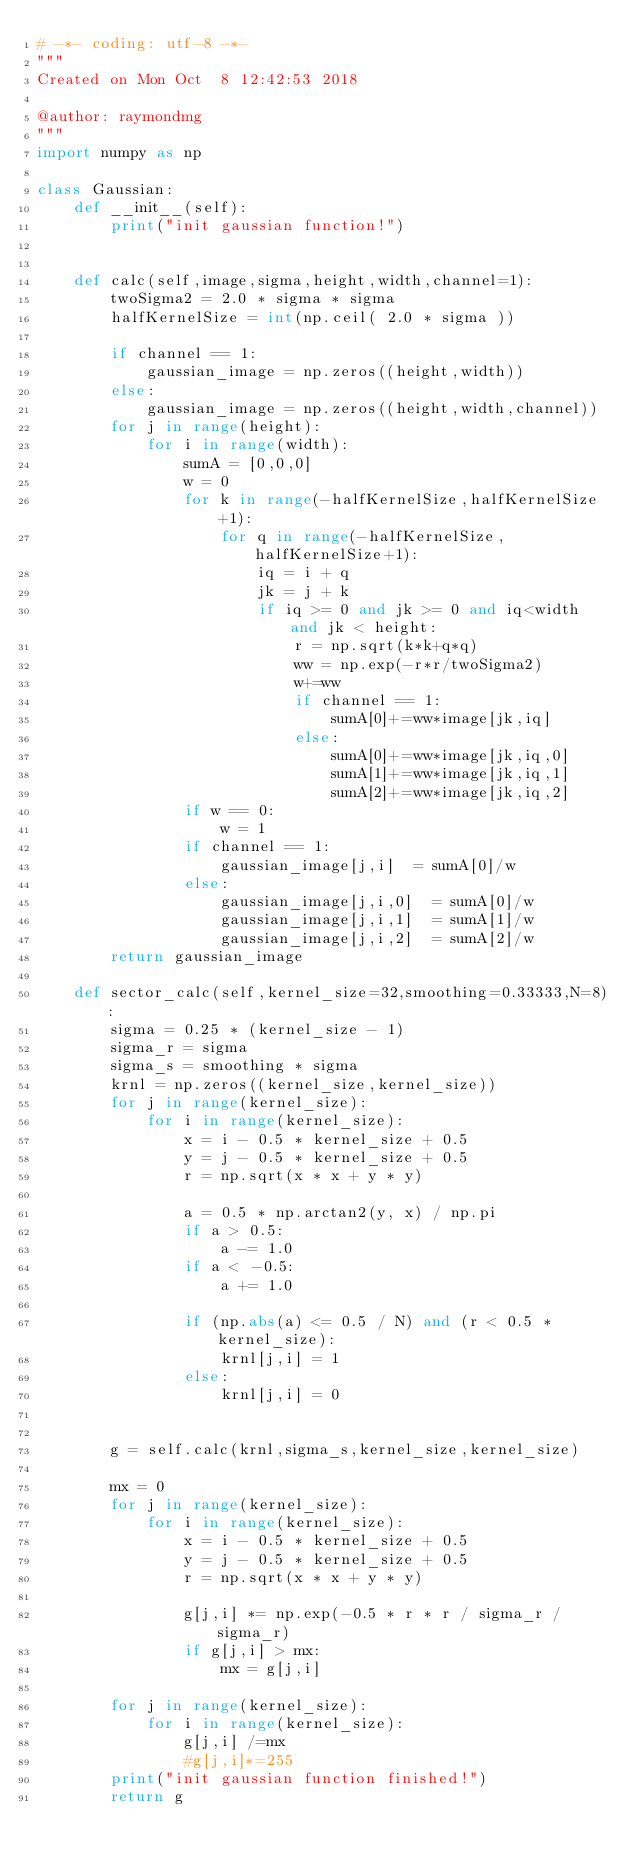<code> <loc_0><loc_0><loc_500><loc_500><_Python_># -*- coding: utf-8 -*-
"""
Created on Mon Oct  8 12:42:53 2018

@author: raymondmg
"""
import numpy as np

class Gaussian:
    def __init__(self):
        print("init gaussian function!")

    
    def calc(self,image,sigma,height,width,channel=1):
        twoSigma2 = 2.0 * sigma * sigma
        halfKernelSize = int(np.ceil( 2.0 * sigma ))
        
        if channel == 1:
            gaussian_image = np.zeros((height,width))
        else:
            gaussian_image = np.zeros((height,width,channel))
        for j in range(height):
            for i in range(width):
                sumA = [0,0,0]
                w = 0
                for k in range(-halfKernelSize,halfKernelSize+1):
                    for q in range(-halfKernelSize,halfKernelSize+1):
                        iq = i + q
                        jk = j + k
                        if iq >= 0 and jk >= 0 and iq<width and jk < height:
                            r = np.sqrt(k*k+q*q)
                            ww = np.exp(-r*r/twoSigma2)
                            w+=ww
                            if channel == 1:
                                sumA[0]+=ww*image[jk,iq]
                            else:
                                sumA[0]+=ww*image[jk,iq,0]
                                sumA[1]+=ww*image[jk,iq,1]
                                sumA[2]+=ww*image[jk,iq,2]
                if w == 0:
                    w = 1
                if channel == 1:
                    gaussian_image[j,i]  = sumA[0]/w
                else:
                    gaussian_image[j,i,0]  = sumA[0]/w
                    gaussian_image[j,i,1]  = sumA[1]/w
                    gaussian_image[j,i,2]  = sumA[2]/w
        return gaussian_image
    
    def sector_calc(self,kernel_size=32,smoothing=0.33333,N=8):
        sigma = 0.25 * (kernel_size - 1)
        sigma_r = sigma
        sigma_s = smoothing * sigma
        krnl = np.zeros((kernel_size,kernel_size))
        for j in range(kernel_size):
            for i in range(kernel_size):
                x = i - 0.5 * kernel_size + 0.5
                y = j - 0.5 * kernel_size + 0.5
                r = np.sqrt(x * x + y * y)
                
                a = 0.5 * np.arctan2(y, x) / np.pi
                if a > 0.5:
                    a -= 1.0
                if a < -0.5:
                    a += 1.0

                if (np.abs(a) <= 0.5 / N) and (r < 0.5 * kernel_size):
                    krnl[j,i] = 1
                else:
                    krnl[j,i] = 0
                
                    
        g = self.calc(krnl,sigma_s,kernel_size,kernel_size)
        
        mx = 0
        for j in range(kernel_size):
            for i in range(kernel_size):
                x = i - 0.5 * kernel_size + 0.5
                y = j - 0.5 * kernel_size + 0.5
                r = np.sqrt(x * x + y * y)
                
                g[j,i] *= np.exp(-0.5 * r * r / sigma_r / sigma_r)
                if g[j,i] > mx:
                    mx = g[j,i]
        
        for j in range(kernel_size):
            for i in range(kernel_size):
                g[j,i] /=mx
                #g[j,i]*=255
        print("init gaussian function finished!")
        return g</code> 